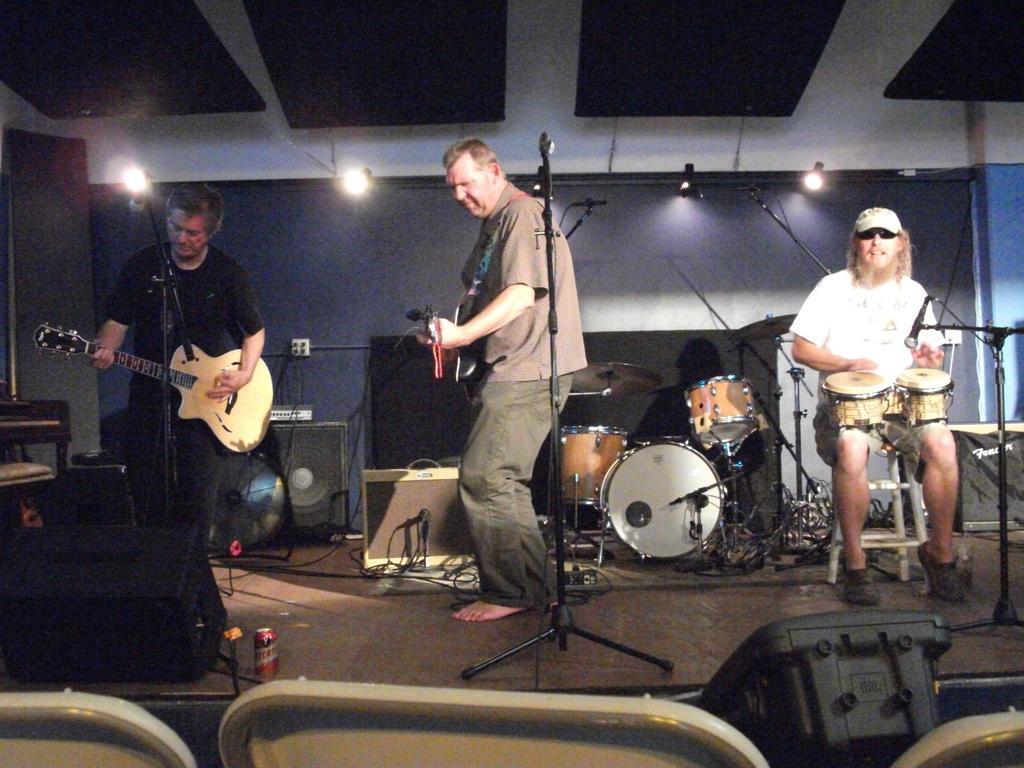Describe this image in one or two sentences. In the foreground of the picture there are chairs. In the center of the picture there is a band performing on stage, on stage there are drums, mics, cables, speakers and other objects. The people are playing guitars and drums. In the background there are lights. 